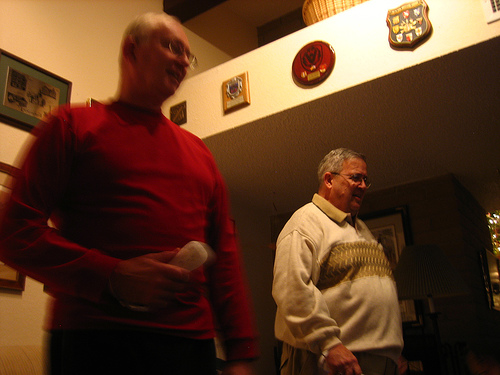Is the person near the sweater wearing jeans? The individual you're referring to is not wearing jeans; they are dressed in trousers of a different material. 